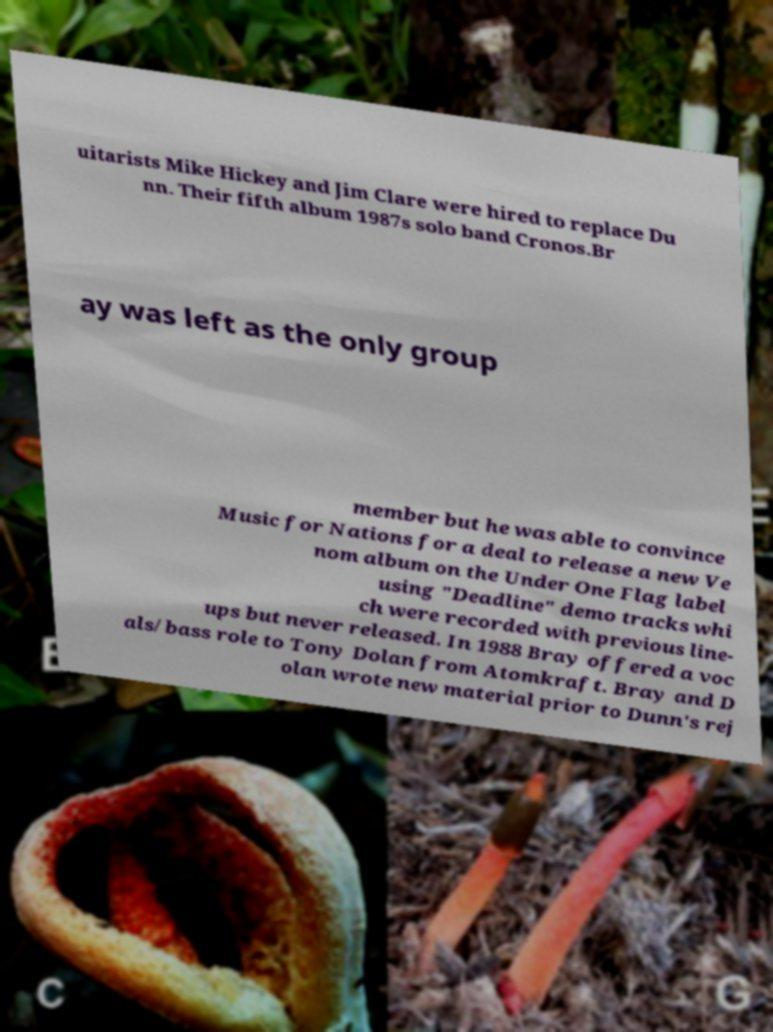What messages or text are displayed in this image? I need them in a readable, typed format. uitarists Mike Hickey and Jim Clare were hired to replace Du nn. Their fifth album 1987s solo band Cronos.Br ay was left as the only group member but he was able to convince Music for Nations for a deal to release a new Ve nom album on the Under One Flag label using "Deadline" demo tracks whi ch were recorded with previous line- ups but never released. In 1988 Bray offered a voc als/bass role to Tony Dolan from Atomkraft. Bray and D olan wrote new material prior to Dunn's rej 